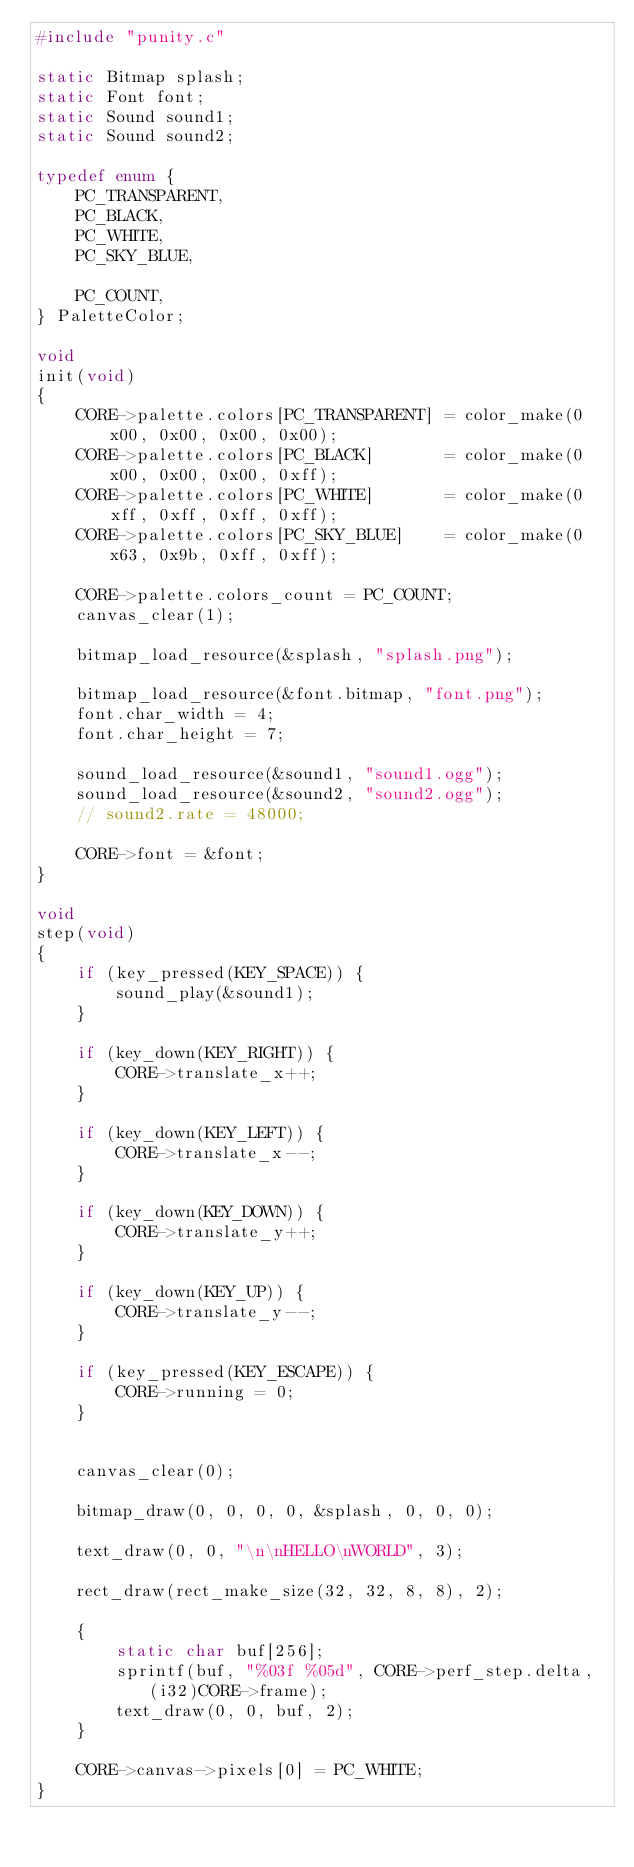Convert code to text. <code><loc_0><loc_0><loc_500><loc_500><_C_>#include "punity.c"

static Bitmap splash;
static Font font;
static Sound sound1;
static Sound sound2;

typedef enum {
	PC_TRANSPARENT,
	PC_BLACK,
	PC_WHITE,
	PC_SKY_BLUE,

	PC_COUNT,
} PaletteColor;

void
init(void)
{
    CORE->palette.colors[PC_TRANSPARENT] = color_make(0x00, 0x00, 0x00, 0x00);
    CORE->palette.colors[PC_BLACK]       = color_make(0x00, 0x00, 0x00, 0xff);
    CORE->palette.colors[PC_WHITE]       = color_make(0xff, 0xff, 0xff, 0xff);
    CORE->palette.colors[PC_SKY_BLUE]    = color_make(0x63, 0x9b, 0xff, 0xff);

    CORE->palette.colors_count = PC_COUNT;
    canvas_clear(1);

	bitmap_load_resource(&splash, "splash.png");

    bitmap_load_resource(&font.bitmap, "font.png");
    font.char_width = 4;
    font.char_height = 7;

    sound_load_resource(&sound1, "sound1.ogg");
	sound_load_resource(&sound2, "sound2.ogg");
	// sound2.rate = 48000;

    CORE->font = &font;
}

void
step(void)
{
	if (key_pressed(KEY_SPACE)) {
		sound_play(&sound1);
	}

	if (key_down(KEY_RIGHT)) {
		CORE->translate_x++;
	}

	if (key_down(KEY_LEFT)) {
		CORE->translate_x--;
	}

	if (key_down(KEY_DOWN)) {
		CORE->translate_y++;
	}

	if (key_down(KEY_UP)) {
		CORE->translate_y--;
	}

	if (key_pressed(KEY_ESCAPE)) {
		CORE->running = 0;
	}


    canvas_clear(0);

    bitmap_draw(0, 0, 0, 0, &splash, 0, 0, 0);

    text_draw(0, 0, "\n\nHELLO\nWORLD", 3);

    rect_draw(rect_make_size(32, 32, 8, 8), 2);

    {
	    static char buf[256];
	    sprintf(buf, "%03f %05d", CORE->perf_step.delta, (i32)CORE->frame);
	    text_draw(0, 0, buf, 2);
	}

	CORE->canvas->pixels[0] = PC_WHITE;
}
</code> 